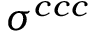<formula> <loc_0><loc_0><loc_500><loc_500>\sigma ^ { c c c }</formula> 